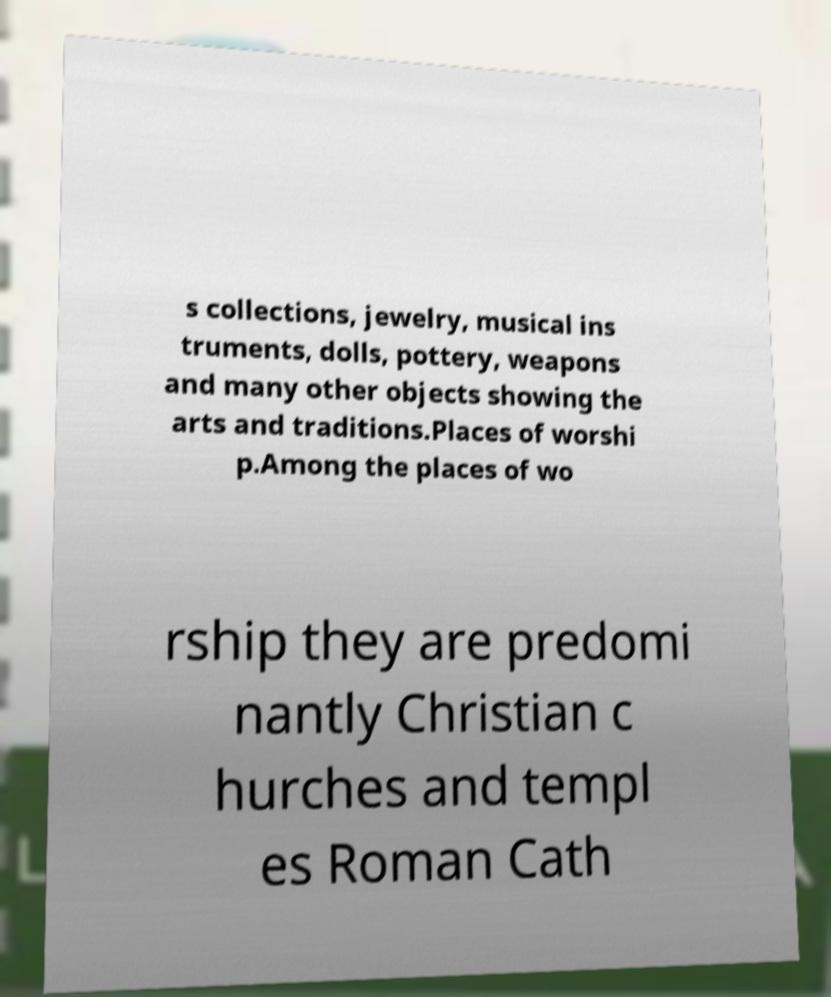For documentation purposes, I need the text within this image transcribed. Could you provide that? s collections, jewelry, musical ins truments, dolls, pottery, weapons and many other objects showing the arts and traditions.Places of worshi p.Among the places of wo rship they are predomi nantly Christian c hurches and templ es Roman Cath 